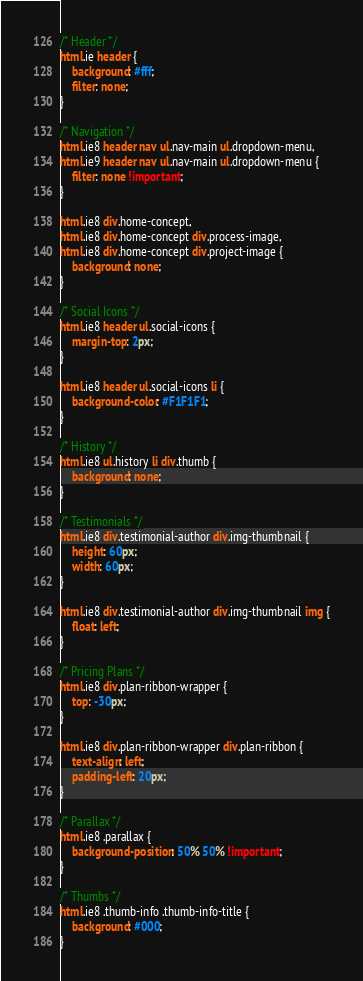<code> <loc_0><loc_0><loc_500><loc_500><_CSS_>
/* Header */
html.ie header {
	background: #fff;
	filter: none;
}

/* Navigation */
html.ie8 header nav ul.nav-main ul.dropdown-menu,
html.ie9 header nav ul.nav-main ul.dropdown-menu {
	filter: none !important;
}

html.ie8 div.home-concept,
html.ie8 div.home-concept div.process-image,
html.ie8 div.home-concept div.project-image {
	background: none;
}

/* Social Icons */
html.ie8 header ul.social-icons {
	margin-top: 2px;
}

html.ie8 header ul.social-icons li {
	background-color: #F1F1F1;
}

/* History */
html.ie8 ul.history li div.thumb {
	background: none;
}

/* Testimonials */
html.ie8 div.testimonial-author div.img-thumbnail {
	height: 60px;
	width: 60px;
}

html.ie8 div.testimonial-author div.img-thumbnail img {
	float: left;
}

/* Pricing Plans */
html.ie8 div.plan-ribbon-wrapper {
	top: -30px;
}

html.ie8 div.plan-ribbon-wrapper div.plan-ribbon {
	text-align: left;
	padding-left: 20px;
}

/* Parallax */
html.ie8 .parallax {
	background-position: 50% 50% !important;
}

/* Thumbs */
html.ie8 .thumb-info .thumb-info-title {
	background: #000;
}
</code> 